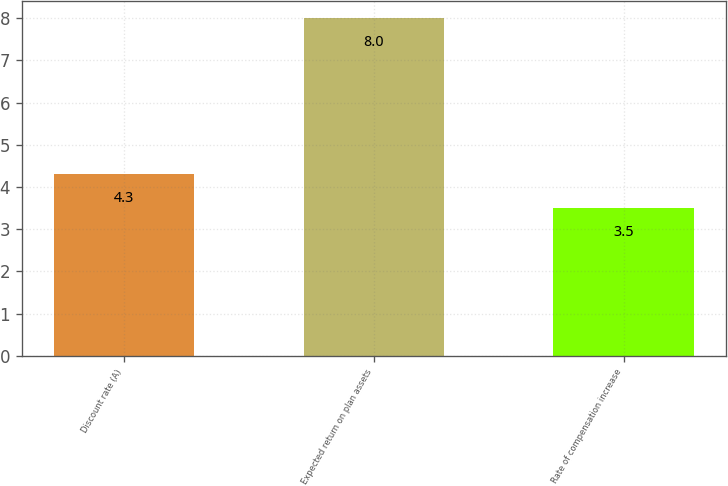<chart> <loc_0><loc_0><loc_500><loc_500><bar_chart><fcel>Discount rate (A)<fcel>Expected return on plan assets<fcel>Rate of compensation increase<nl><fcel>4.3<fcel>8<fcel>3.5<nl></chart> 